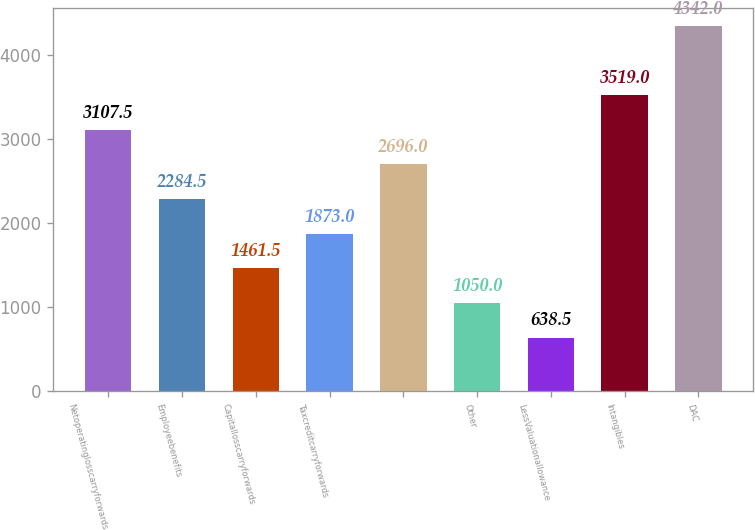<chart> <loc_0><loc_0><loc_500><loc_500><bar_chart><fcel>Netoperatinglosscarryforwards<fcel>Employeebenefits<fcel>Capitallosscarryforwards<fcel>Taxcreditcarryforwards<fcel>Unnamed: 4<fcel>Other<fcel>LessValuationallowance<fcel>Intangibles<fcel>DAC<nl><fcel>3107.5<fcel>2284.5<fcel>1461.5<fcel>1873<fcel>2696<fcel>1050<fcel>638.5<fcel>3519<fcel>4342<nl></chart> 